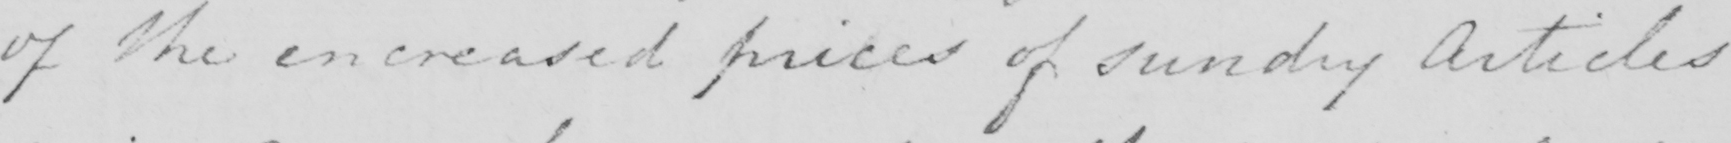Can you tell me what this handwritten text says? of the encreased prices of sundry Articles 